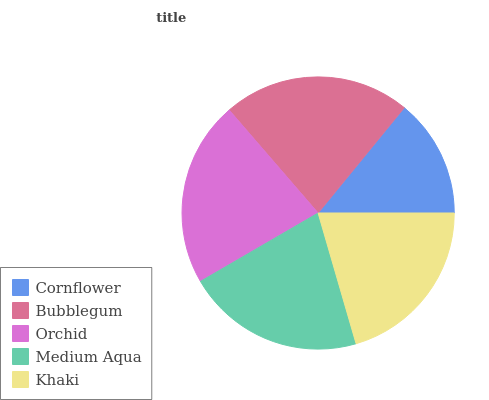Is Cornflower the minimum?
Answer yes or no. Yes. Is Bubblegum the maximum?
Answer yes or no. Yes. Is Orchid the minimum?
Answer yes or no. No. Is Orchid the maximum?
Answer yes or no. No. Is Bubblegum greater than Orchid?
Answer yes or no. Yes. Is Orchid less than Bubblegum?
Answer yes or no. Yes. Is Orchid greater than Bubblegum?
Answer yes or no. No. Is Bubblegum less than Orchid?
Answer yes or no. No. Is Medium Aqua the high median?
Answer yes or no. Yes. Is Medium Aqua the low median?
Answer yes or no. Yes. Is Orchid the high median?
Answer yes or no. No. Is Bubblegum the low median?
Answer yes or no. No. 